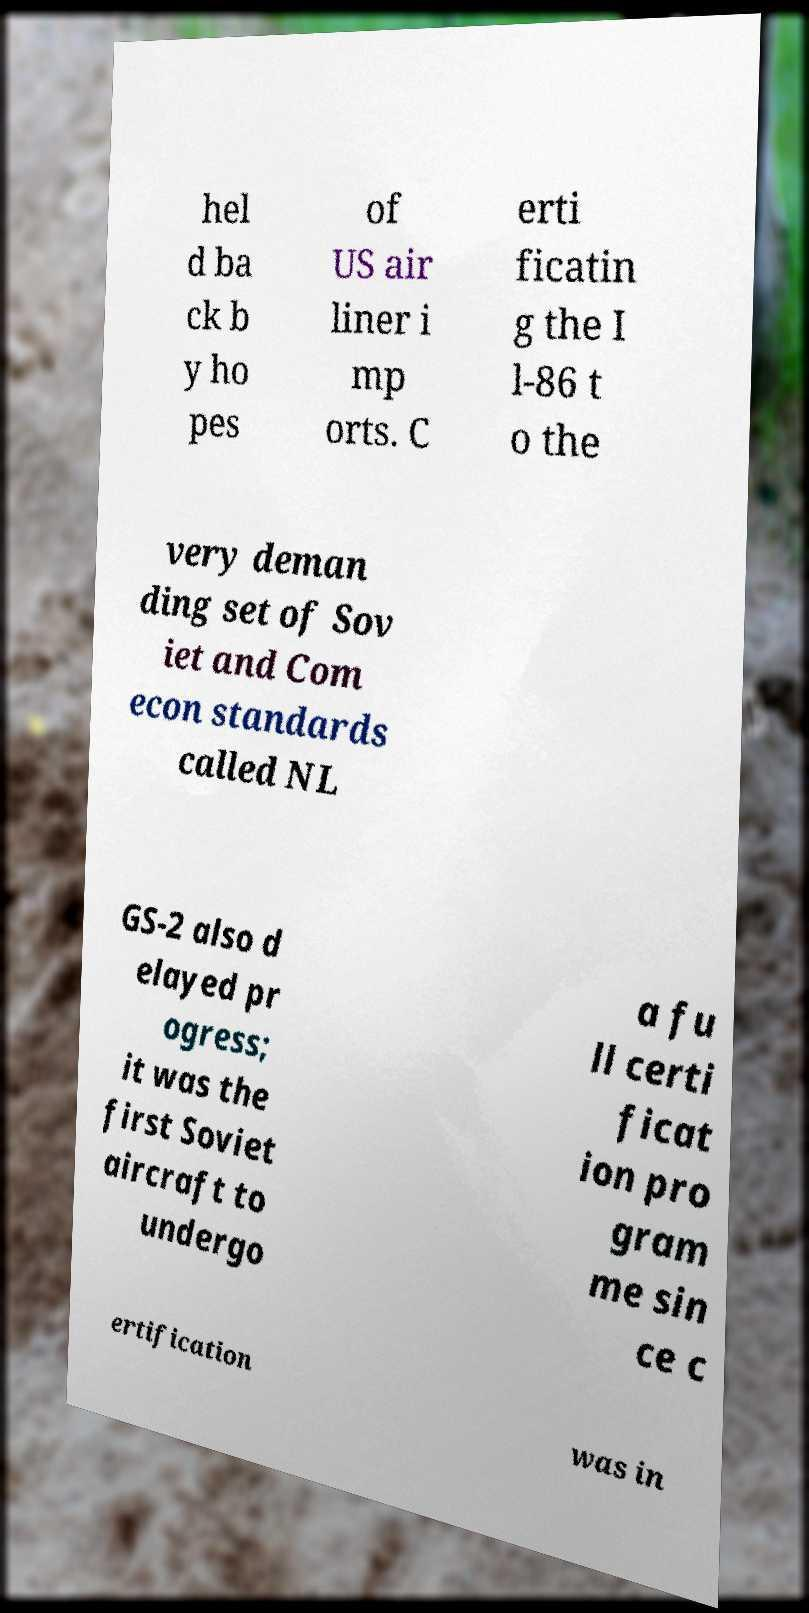Could you assist in decoding the text presented in this image and type it out clearly? hel d ba ck b y ho pes of US air liner i mp orts. C erti ficatin g the I l-86 t o the very deman ding set of Sov iet and Com econ standards called NL GS-2 also d elayed pr ogress; it was the first Soviet aircraft to undergo a fu ll certi ficat ion pro gram me sin ce c ertification was in 